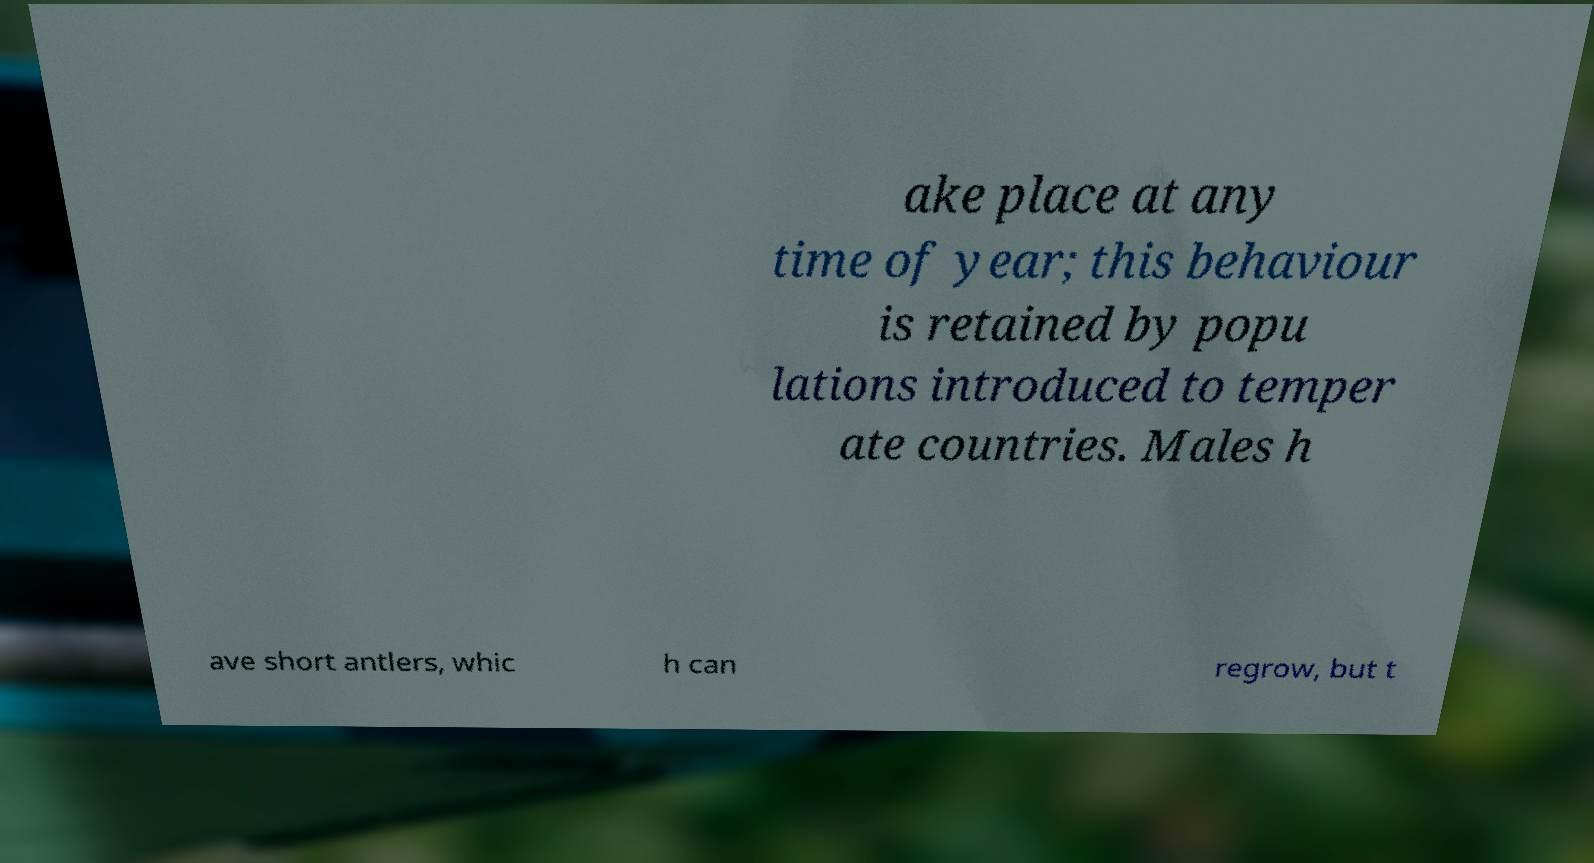Can you accurately transcribe the text from the provided image for me? ake place at any time of year; this behaviour is retained by popu lations introduced to temper ate countries. Males h ave short antlers, whic h can regrow, but t 